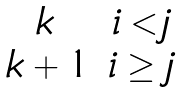<formula> <loc_0><loc_0><loc_500><loc_500>\begin{matrix} k & i < j \\ \, k + 1 & i \geq j \end{matrix}</formula> 